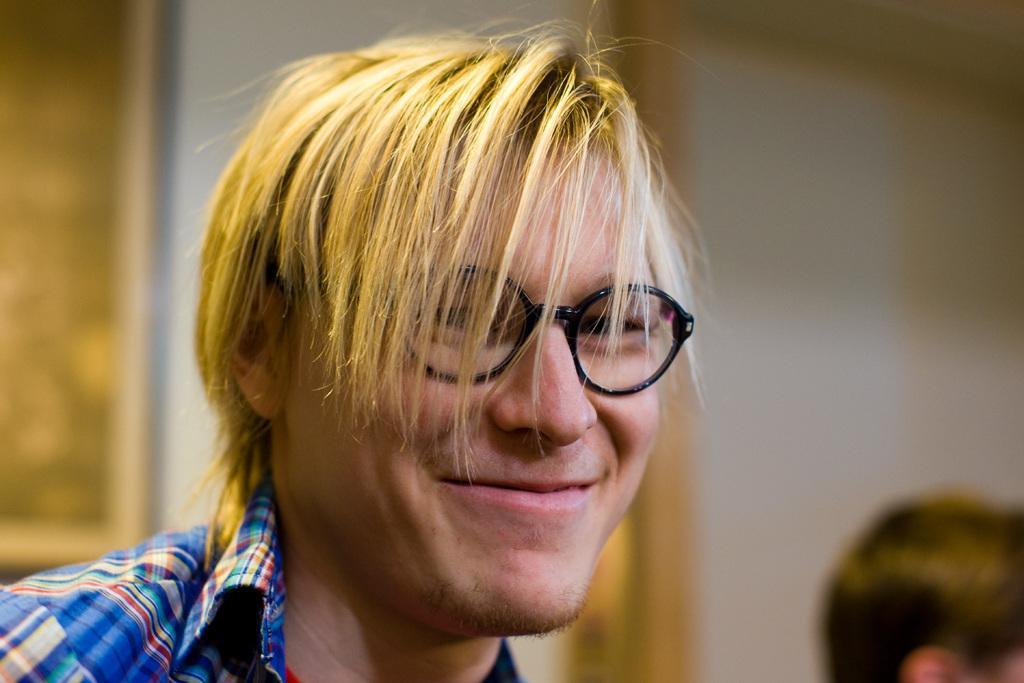Can you describe this image briefly? This is the picture of a person wearing spectacles and has short hair. 